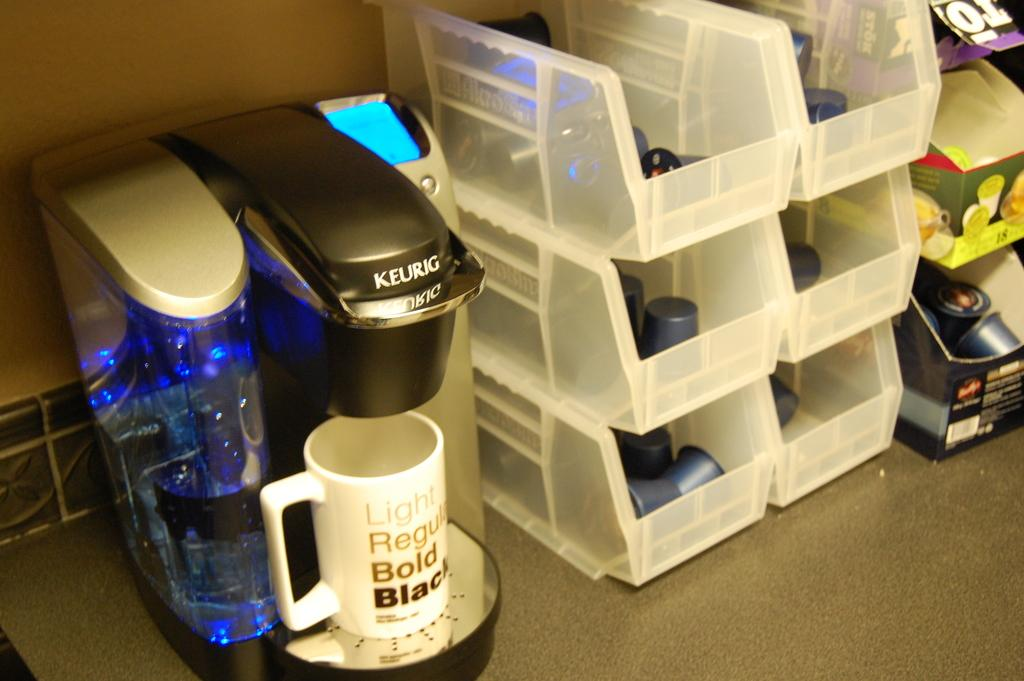<image>
Offer a succinct explanation of the picture presented. A Keurig with a white coffee cup that says Light Regular Bold Black sits next to white bins with k-cups in them. 